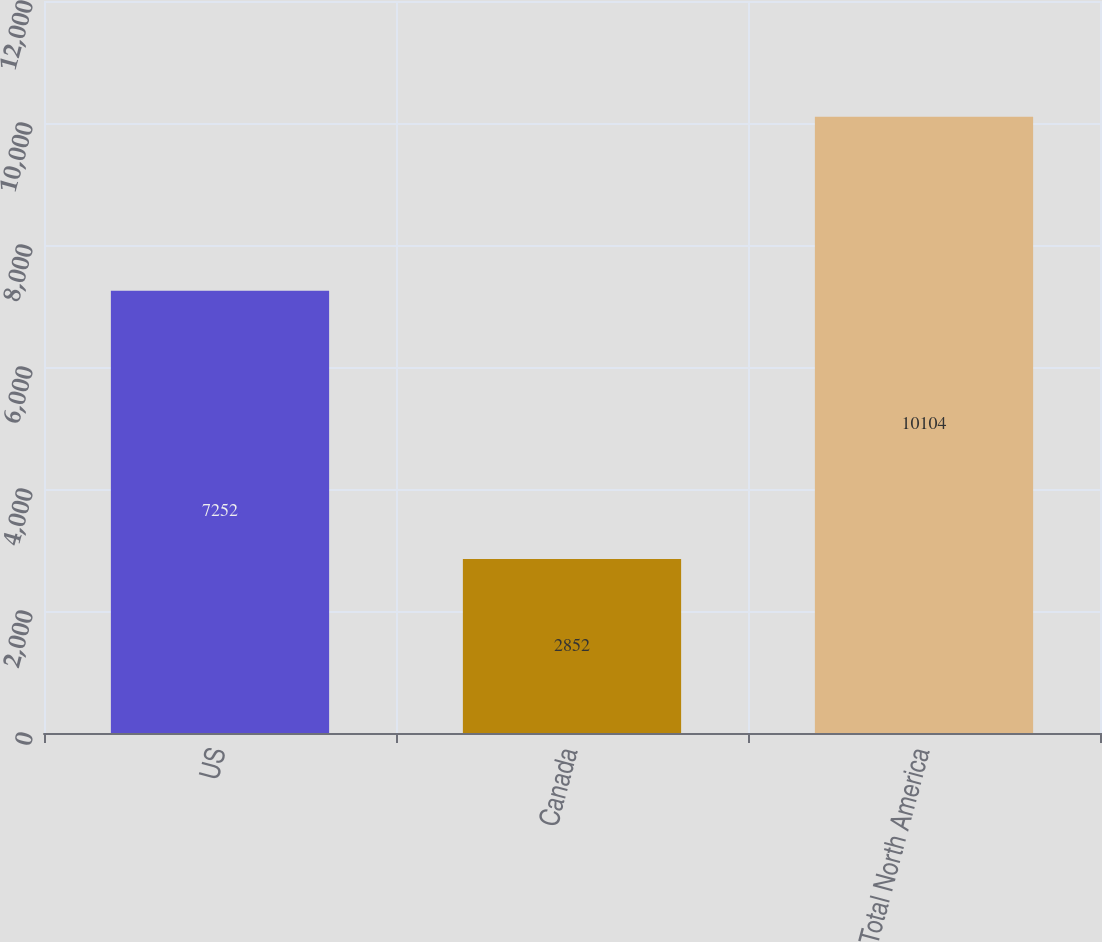Convert chart. <chart><loc_0><loc_0><loc_500><loc_500><bar_chart><fcel>US<fcel>Canada<fcel>Total North America<nl><fcel>7252<fcel>2852<fcel>10104<nl></chart> 